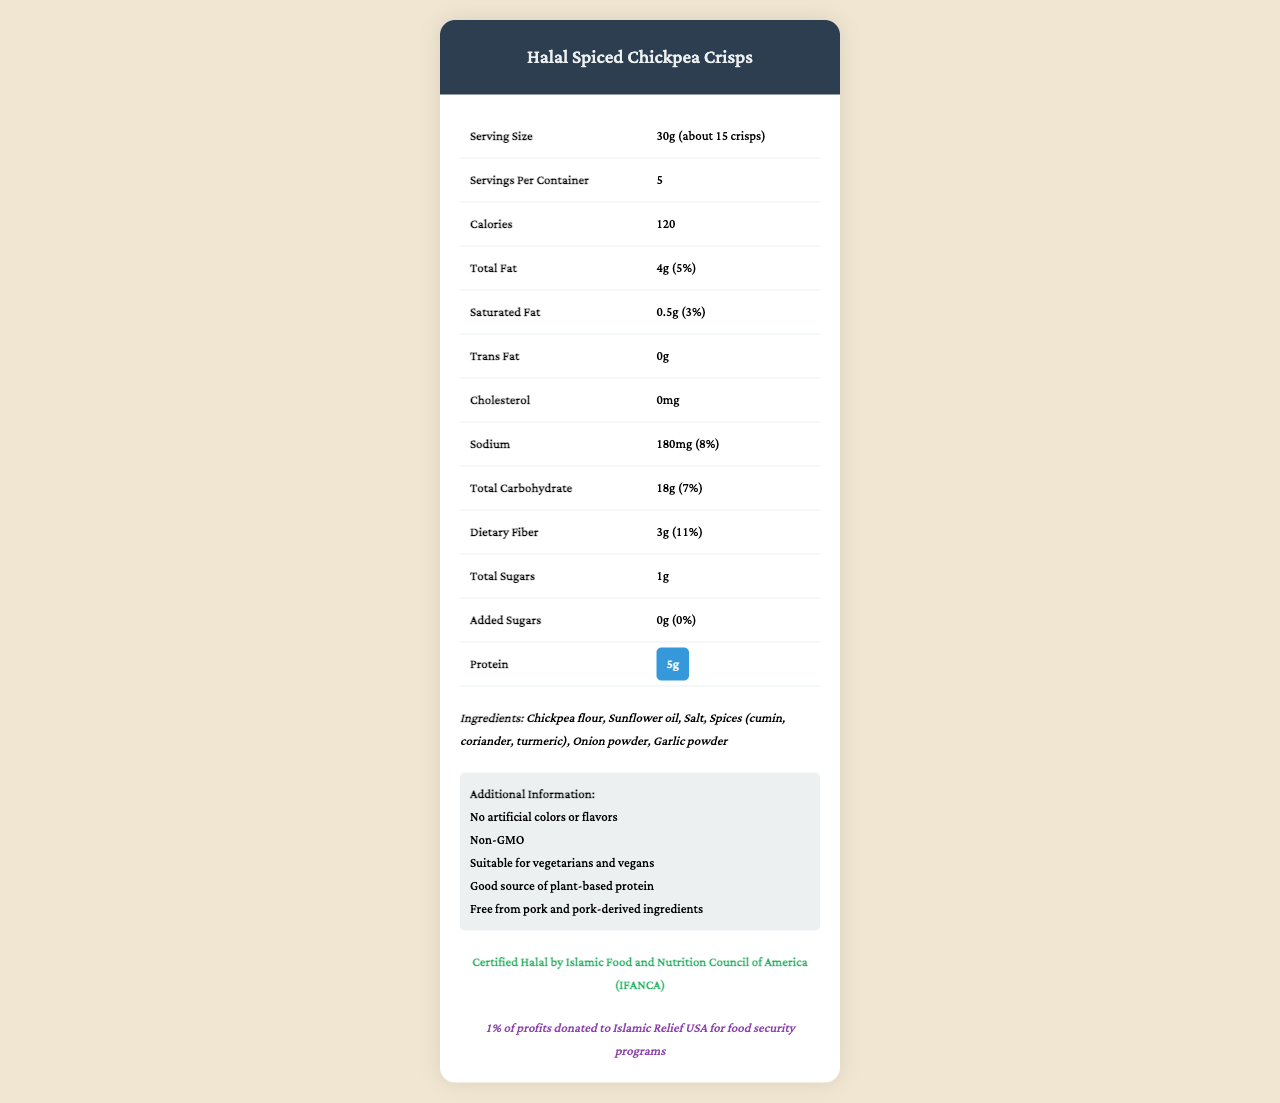What is the serving size of the Halal Spiced Chickpea Crisps? The serving size is clearly mentioned in the nutrition facts as "30g (about 15 crisps)".
Answer: 30g How many grams of protein are in one serving? The nutrition label highlights the protein content as 5g per serving.
Answer: 5g Is there any pork-derived ingredient in the Halal Spiced Chickpea Crisps? The additional information section states that the product is "Free from pork and pork-derived ingredients".
Answer: No Which organization certified the Halal status of this product? The document states that the product is "Certified Halal by Islamic Food and Nutrition Council of America (IFANCA)".
Answer: Islamic Food and Nutrition Council of America (IFANCA) How much calcium does one serving of this snack provide? The content of calcium per serving is listed as "20mg".
Answer: 20mg What is the main source of protein in the Halal Spiced Chickpea Crisps? A. Chicken B. Beef C. Plant-based D. Fish The document mentions "Good source of plant-based protein" in the additional information section.
Answer: C Which of the following ingredients are NOT listed in the Halal Spiced Chickpea Crisps? A. Sunflower oil B. Salt C. Corn syrup D. Garlic powder The ingredients list does not include corn syrup, it includes chickpea flour, sunflower oil, salt, spices, onion powder, and garlic powder.
Answer: C. Corn syrup What percentage of the daily value of dietary fiber does one serving provide? The daily value percentage for dietary fiber is mentioned as 11%.
Answer: 11% Is this snack suitable for vegetarians? The additional information section states that the product is "Suitable for vegetarians and vegans".
Answer: Yes What is the main idea of this document? The document summarizes the nutritional facts, ingredients, Halal certification details, and a social justice initiative tied to the product.
Answer: This document provides nutritional information about Halal Spiced Chickpea Crisps, highlighting their Halal certification, protein content, absence of pork-derived ingredients, and the product's socially responsible initiative. Can you determine the price of the Halal Spiced Chickpea Crisps from this document? The document does not provide any information regarding the price of the product.
Answer: Not enough information 